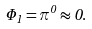<formula> <loc_0><loc_0><loc_500><loc_500>\Phi _ { 1 } = \pi ^ { 0 } \approx 0 .</formula> 